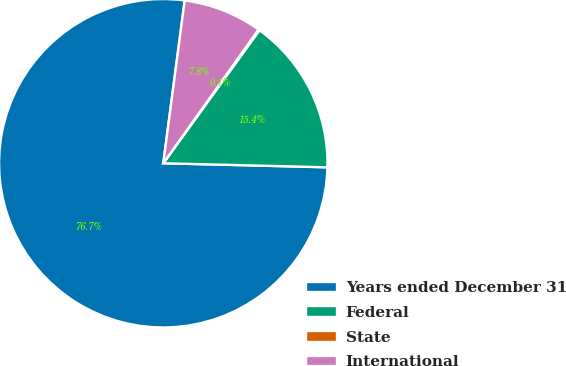Convert chart to OTSL. <chart><loc_0><loc_0><loc_500><loc_500><pie_chart><fcel>Years ended December 31<fcel>Federal<fcel>State<fcel>International<nl><fcel>76.69%<fcel>15.43%<fcel>0.11%<fcel>7.77%<nl></chart> 